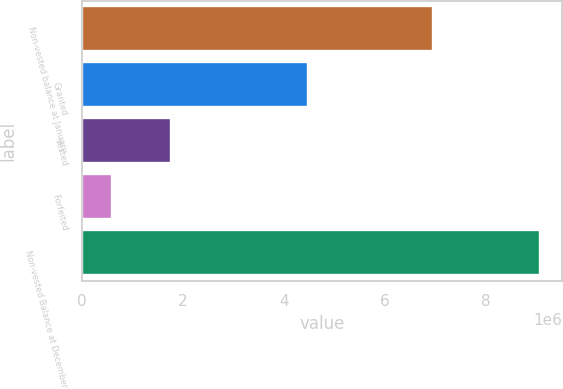<chart> <loc_0><loc_0><loc_500><loc_500><bar_chart><fcel>Non-vested balance at January<fcel>Granted<fcel>Vested<fcel>Forfeited<fcel>Non-vested Balance at December<nl><fcel>6.9604e+06<fcel>4.47851e+06<fcel>1.76489e+06<fcel>606156<fcel>9.06787e+06<nl></chart> 